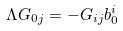<formula> <loc_0><loc_0><loc_500><loc_500>\Lambda G _ { 0 j } = - G _ { i j } b _ { 0 } ^ { i }</formula> 